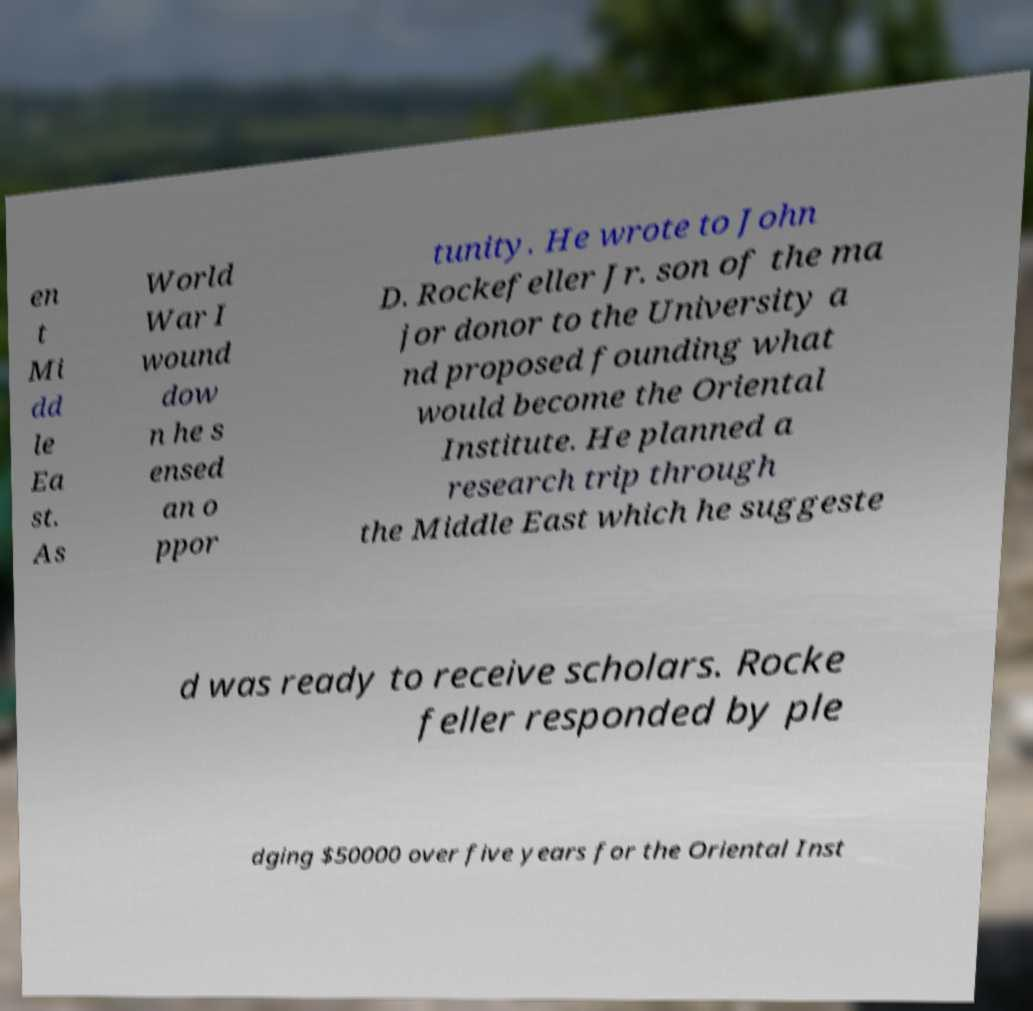Please identify and transcribe the text found in this image. en t Mi dd le Ea st. As World War I wound dow n he s ensed an o ppor tunity. He wrote to John D. Rockefeller Jr. son of the ma jor donor to the University a nd proposed founding what would become the Oriental Institute. He planned a research trip through the Middle East which he suggeste d was ready to receive scholars. Rocke feller responded by ple dging $50000 over five years for the Oriental Inst 